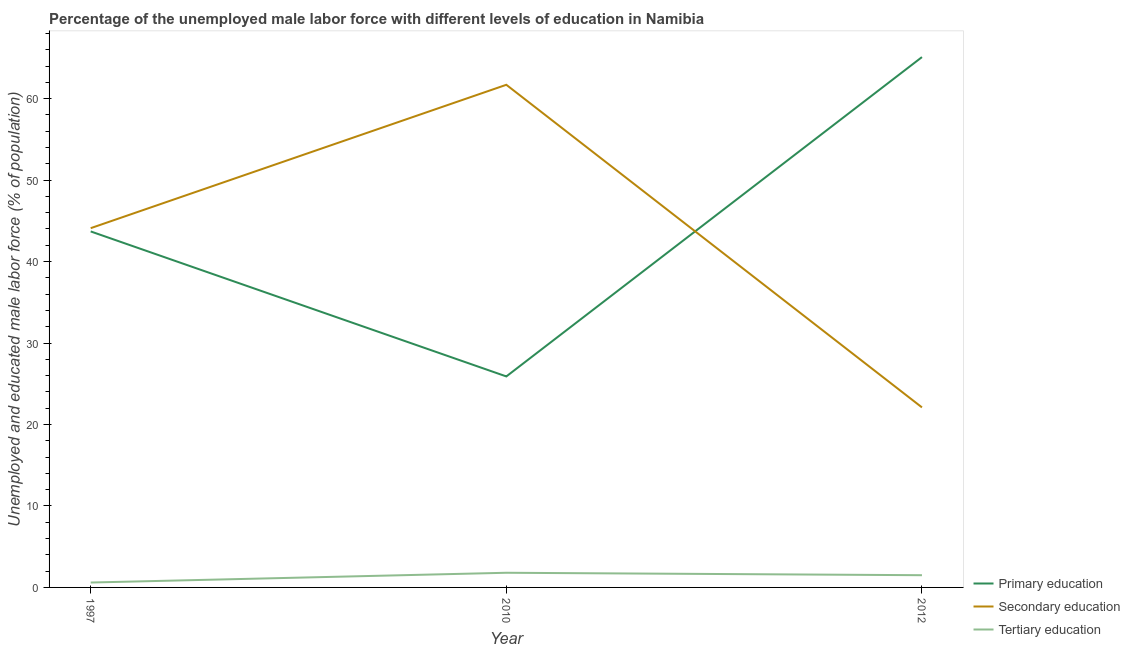Is the number of lines equal to the number of legend labels?
Give a very brief answer. Yes. What is the percentage of male labor force who received tertiary education in 2010?
Provide a succinct answer. 1.8. Across all years, what is the maximum percentage of male labor force who received tertiary education?
Offer a very short reply. 1.8. Across all years, what is the minimum percentage of male labor force who received secondary education?
Your response must be concise. 22.1. In which year was the percentage of male labor force who received tertiary education minimum?
Keep it short and to the point. 1997. What is the total percentage of male labor force who received primary education in the graph?
Ensure brevity in your answer.  134.7. What is the difference between the percentage of male labor force who received secondary education in 1997 and that in 2010?
Your answer should be compact. -17.6. What is the difference between the percentage of male labor force who received secondary education in 2010 and the percentage of male labor force who received tertiary education in 1997?
Ensure brevity in your answer.  61.1. What is the average percentage of male labor force who received secondary education per year?
Give a very brief answer. 42.63. In the year 2012, what is the difference between the percentage of male labor force who received primary education and percentage of male labor force who received tertiary education?
Offer a very short reply. 63.6. In how many years, is the percentage of male labor force who received tertiary education greater than 18 %?
Your answer should be compact. 0. What is the ratio of the percentage of male labor force who received secondary education in 2010 to that in 2012?
Give a very brief answer. 2.79. What is the difference between the highest and the second highest percentage of male labor force who received tertiary education?
Your answer should be compact. 0.3. What is the difference between the highest and the lowest percentage of male labor force who received primary education?
Give a very brief answer. 39.2. Is the sum of the percentage of male labor force who received primary education in 1997 and 2012 greater than the maximum percentage of male labor force who received secondary education across all years?
Your answer should be compact. Yes. Does the percentage of male labor force who received tertiary education monotonically increase over the years?
Offer a very short reply. No. How many lines are there?
Offer a terse response. 3. How many years are there in the graph?
Give a very brief answer. 3. What is the difference between two consecutive major ticks on the Y-axis?
Your answer should be compact. 10. Are the values on the major ticks of Y-axis written in scientific E-notation?
Offer a very short reply. No. Does the graph contain any zero values?
Provide a short and direct response. No. Does the graph contain grids?
Keep it short and to the point. No. Where does the legend appear in the graph?
Ensure brevity in your answer.  Bottom right. What is the title of the graph?
Provide a short and direct response. Percentage of the unemployed male labor force with different levels of education in Namibia. What is the label or title of the X-axis?
Provide a succinct answer. Year. What is the label or title of the Y-axis?
Your response must be concise. Unemployed and educated male labor force (% of population). What is the Unemployed and educated male labor force (% of population) in Primary education in 1997?
Your answer should be very brief. 43.7. What is the Unemployed and educated male labor force (% of population) in Secondary education in 1997?
Ensure brevity in your answer.  44.1. What is the Unemployed and educated male labor force (% of population) in Tertiary education in 1997?
Your response must be concise. 0.6. What is the Unemployed and educated male labor force (% of population) in Primary education in 2010?
Give a very brief answer. 25.9. What is the Unemployed and educated male labor force (% of population) of Secondary education in 2010?
Your answer should be compact. 61.7. What is the Unemployed and educated male labor force (% of population) in Tertiary education in 2010?
Keep it short and to the point. 1.8. What is the Unemployed and educated male labor force (% of population) in Primary education in 2012?
Provide a short and direct response. 65.1. What is the Unemployed and educated male labor force (% of population) in Secondary education in 2012?
Provide a short and direct response. 22.1. What is the Unemployed and educated male labor force (% of population) of Tertiary education in 2012?
Your answer should be compact. 1.5. Across all years, what is the maximum Unemployed and educated male labor force (% of population) in Primary education?
Provide a succinct answer. 65.1. Across all years, what is the maximum Unemployed and educated male labor force (% of population) of Secondary education?
Provide a succinct answer. 61.7. Across all years, what is the maximum Unemployed and educated male labor force (% of population) in Tertiary education?
Your answer should be very brief. 1.8. Across all years, what is the minimum Unemployed and educated male labor force (% of population) in Primary education?
Keep it short and to the point. 25.9. Across all years, what is the minimum Unemployed and educated male labor force (% of population) in Secondary education?
Make the answer very short. 22.1. Across all years, what is the minimum Unemployed and educated male labor force (% of population) of Tertiary education?
Keep it short and to the point. 0.6. What is the total Unemployed and educated male labor force (% of population) in Primary education in the graph?
Your response must be concise. 134.7. What is the total Unemployed and educated male labor force (% of population) in Secondary education in the graph?
Keep it short and to the point. 127.9. What is the difference between the Unemployed and educated male labor force (% of population) in Primary education in 1997 and that in 2010?
Offer a very short reply. 17.8. What is the difference between the Unemployed and educated male labor force (% of population) in Secondary education in 1997 and that in 2010?
Provide a succinct answer. -17.6. What is the difference between the Unemployed and educated male labor force (% of population) in Primary education in 1997 and that in 2012?
Keep it short and to the point. -21.4. What is the difference between the Unemployed and educated male labor force (% of population) in Primary education in 2010 and that in 2012?
Offer a very short reply. -39.2. What is the difference between the Unemployed and educated male labor force (% of population) in Secondary education in 2010 and that in 2012?
Your answer should be very brief. 39.6. What is the difference between the Unemployed and educated male labor force (% of population) of Primary education in 1997 and the Unemployed and educated male labor force (% of population) of Tertiary education in 2010?
Keep it short and to the point. 41.9. What is the difference between the Unemployed and educated male labor force (% of population) in Secondary education in 1997 and the Unemployed and educated male labor force (% of population) in Tertiary education in 2010?
Make the answer very short. 42.3. What is the difference between the Unemployed and educated male labor force (% of population) of Primary education in 1997 and the Unemployed and educated male labor force (% of population) of Secondary education in 2012?
Your response must be concise. 21.6. What is the difference between the Unemployed and educated male labor force (% of population) of Primary education in 1997 and the Unemployed and educated male labor force (% of population) of Tertiary education in 2012?
Offer a very short reply. 42.2. What is the difference between the Unemployed and educated male labor force (% of population) of Secondary education in 1997 and the Unemployed and educated male labor force (% of population) of Tertiary education in 2012?
Your answer should be very brief. 42.6. What is the difference between the Unemployed and educated male labor force (% of population) of Primary education in 2010 and the Unemployed and educated male labor force (% of population) of Secondary education in 2012?
Offer a terse response. 3.8. What is the difference between the Unemployed and educated male labor force (% of population) of Primary education in 2010 and the Unemployed and educated male labor force (% of population) of Tertiary education in 2012?
Provide a short and direct response. 24.4. What is the difference between the Unemployed and educated male labor force (% of population) in Secondary education in 2010 and the Unemployed and educated male labor force (% of population) in Tertiary education in 2012?
Provide a short and direct response. 60.2. What is the average Unemployed and educated male labor force (% of population) in Primary education per year?
Your answer should be compact. 44.9. What is the average Unemployed and educated male labor force (% of population) of Secondary education per year?
Ensure brevity in your answer.  42.63. What is the average Unemployed and educated male labor force (% of population) of Tertiary education per year?
Make the answer very short. 1.3. In the year 1997, what is the difference between the Unemployed and educated male labor force (% of population) in Primary education and Unemployed and educated male labor force (% of population) in Tertiary education?
Your answer should be compact. 43.1. In the year 1997, what is the difference between the Unemployed and educated male labor force (% of population) of Secondary education and Unemployed and educated male labor force (% of population) of Tertiary education?
Provide a short and direct response. 43.5. In the year 2010, what is the difference between the Unemployed and educated male labor force (% of population) in Primary education and Unemployed and educated male labor force (% of population) in Secondary education?
Offer a very short reply. -35.8. In the year 2010, what is the difference between the Unemployed and educated male labor force (% of population) in Primary education and Unemployed and educated male labor force (% of population) in Tertiary education?
Your response must be concise. 24.1. In the year 2010, what is the difference between the Unemployed and educated male labor force (% of population) in Secondary education and Unemployed and educated male labor force (% of population) in Tertiary education?
Keep it short and to the point. 59.9. In the year 2012, what is the difference between the Unemployed and educated male labor force (% of population) in Primary education and Unemployed and educated male labor force (% of population) in Secondary education?
Offer a terse response. 43. In the year 2012, what is the difference between the Unemployed and educated male labor force (% of population) of Primary education and Unemployed and educated male labor force (% of population) of Tertiary education?
Provide a short and direct response. 63.6. In the year 2012, what is the difference between the Unemployed and educated male labor force (% of population) in Secondary education and Unemployed and educated male labor force (% of population) in Tertiary education?
Make the answer very short. 20.6. What is the ratio of the Unemployed and educated male labor force (% of population) in Primary education in 1997 to that in 2010?
Provide a short and direct response. 1.69. What is the ratio of the Unemployed and educated male labor force (% of population) in Secondary education in 1997 to that in 2010?
Give a very brief answer. 0.71. What is the ratio of the Unemployed and educated male labor force (% of population) in Primary education in 1997 to that in 2012?
Offer a terse response. 0.67. What is the ratio of the Unemployed and educated male labor force (% of population) of Secondary education in 1997 to that in 2012?
Offer a very short reply. 2. What is the ratio of the Unemployed and educated male labor force (% of population) of Tertiary education in 1997 to that in 2012?
Provide a short and direct response. 0.4. What is the ratio of the Unemployed and educated male labor force (% of population) in Primary education in 2010 to that in 2012?
Your answer should be very brief. 0.4. What is the ratio of the Unemployed and educated male labor force (% of population) in Secondary education in 2010 to that in 2012?
Your answer should be very brief. 2.79. What is the difference between the highest and the second highest Unemployed and educated male labor force (% of population) of Primary education?
Make the answer very short. 21.4. What is the difference between the highest and the second highest Unemployed and educated male labor force (% of population) of Secondary education?
Offer a very short reply. 17.6. What is the difference between the highest and the lowest Unemployed and educated male labor force (% of population) of Primary education?
Offer a terse response. 39.2. What is the difference between the highest and the lowest Unemployed and educated male labor force (% of population) in Secondary education?
Keep it short and to the point. 39.6. What is the difference between the highest and the lowest Unemployed and educated male labor force (% of population) in Tertiary education?
Provide a short and direct response. 1.2. 